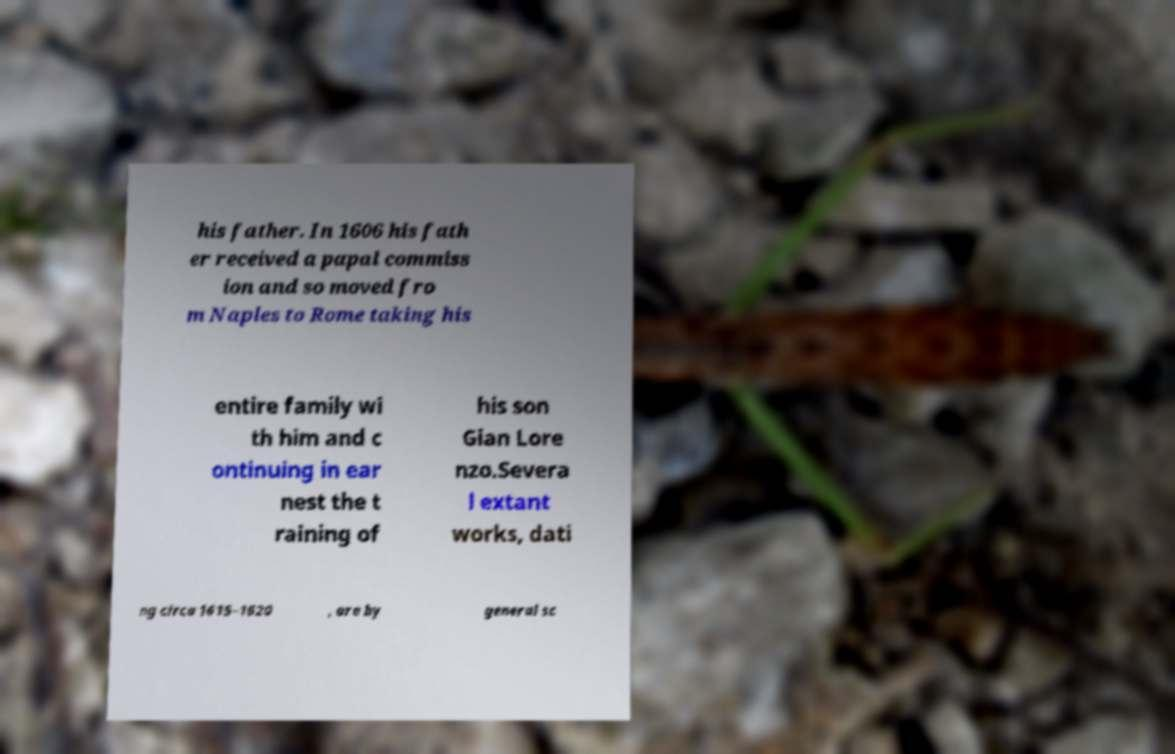What messages or text are displayed in this image? I need them in a readable, typed format. his father. In 1606 his fath er received a papal commiss ion and so moved fro m Naples to Rome taking his entire family wi th him and c ontinuing in ear nest the t raining of his son Gian Lore nzo.Severa l extant works, dati ng circa 1615–1620 , are by general sc 